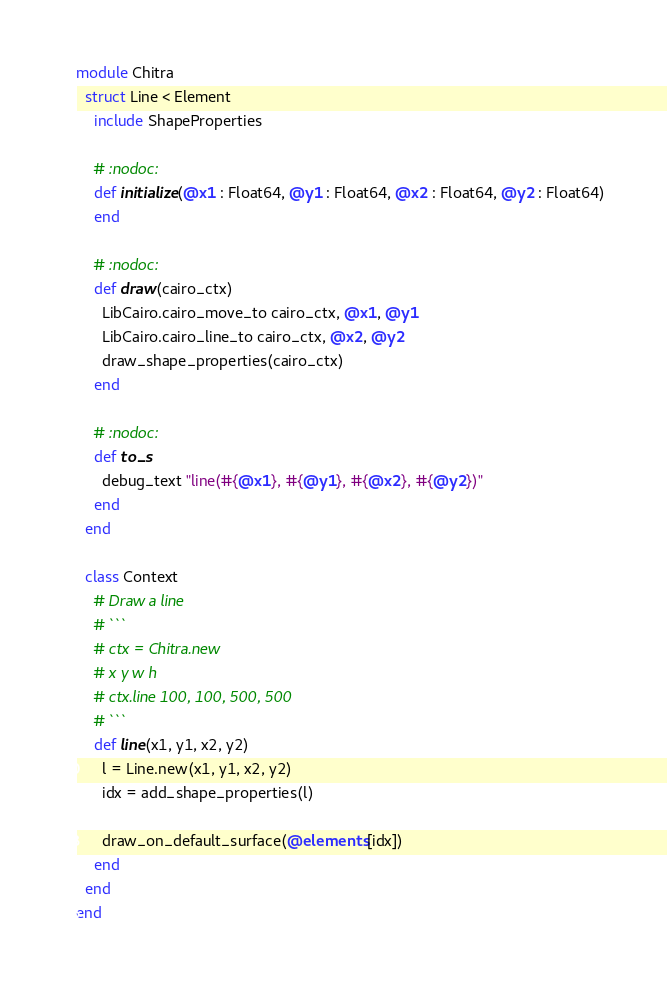Convert code to text. <code><loc_0><loc_0><loc_500><loc_500><_Crystal_>module Chitra
  struct Line < Element
    include ShapeProperties

    # :nodoc:
    def initialize(@x1 : Float64, @y1 : Float64, @x2 : Float64, @y2 : Float64)
    end

    # :nodoc:
    def draw(cairo_ctx)
      LibCairo.cairo_move_to cairo_ctx, @x1, @y1
      LibCairo.cairo_line_to cairo_ctx, @x2, @y2
      draw_shape_properties(cairo_ctx)
    end

    # :nodoc:
    def to_s
      debug_text "line(#{@x1}, #{@y1}, #{@x2}, #{@y2})"
    end
  end

  class Context
    # Draw a line
    # ```
    # ctx = Chitra.new
    # x y w h
    # ctx.line 100, 100, 500, 500
    # ```
    def line(x1, y1, x2, y2)
      l = Line.new(x1, y1, x2, y2)
      idx = add_shape_properties(l)

      draw_on_default_surface(@elements[idx])
    end
  end
end
</code> 